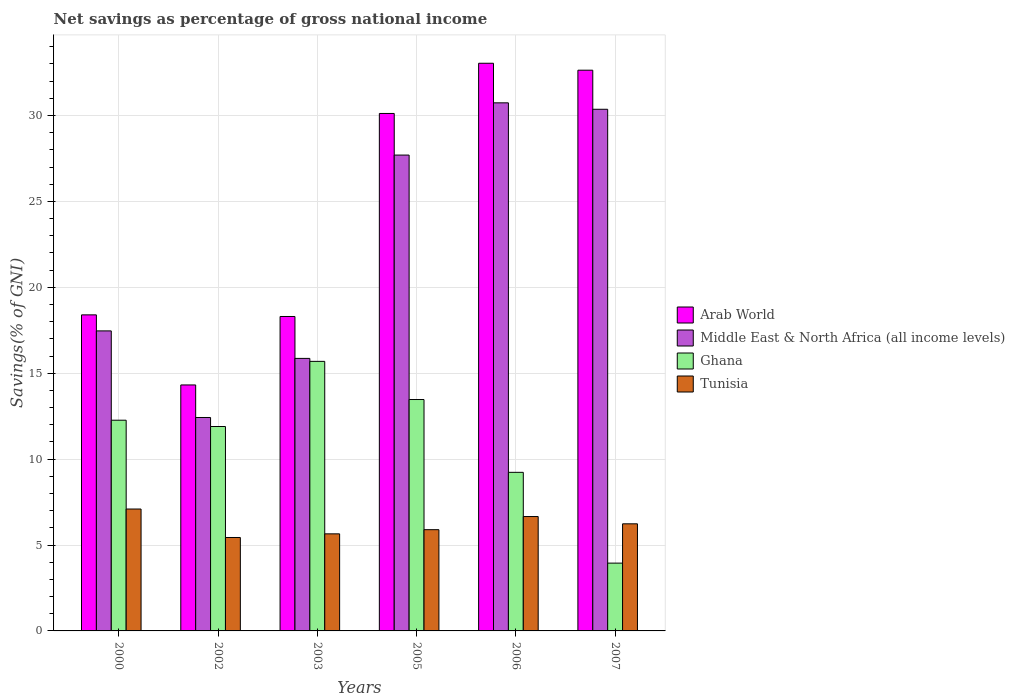Are the number of bars per tick equal to the number of legend labels?
Keep it short and to the point. Yes. How many bars are there on the 5th tick from the right?
Your response must be concise. 4. What is the total savings in Middle East & North Africa (all income levels) in 2002?
Your response must be concise. 12.42. Across all years, what is the maximum total savings in Tunisia?
Provide a succinct answer. 7.09. Across all years, what is the minimum total savings in Middle East & North Africa (all income levels)?
Provide a succinct answer. 12.42. What is the total total savings in Ghana in the graph?
Give a very brief answer. 66.49. What is the difference between the total savings in Tunisia in 2006 and that in 2007?
Give a very brief answer. 0.42. What is the difference between the total savings in Arab World in 2003 and the total savings in Ghana in 2002?
Offer a very short reply. 6.4. What is the average total savings in Tunisia per year?
Provide a succinct answer. 6.16. In the year 2007, what is the difference between the total savings in Tunisia and total savings in Arab World?
Ensure brevity in your answer.  -26.4. In how many years, is the total savings in Tunisia greater than 9 %?
Keep it short and to the point. 0. What is the ratio of the total savings in Tunisia in 2003 to that in 2005?
Your response must be concise. 0.96. Is the total savings in Middle East & North Africa (all income levels) in 2002 less than that in 2007?
Offer a terse response. Yes. Is the difference between the total savings in Tunisia in 2002 and 2007 greater than the difference between the total savings in Arab World in 2002 and 2007?
Make the answer very short. Yes. What is the difference between the highest and the second highest total savings in Ghana?
Make the answer very short. 2.22. What is the difference between the highest and the lowest total savings in Middle East & North Africa (all income levels)?
Your response must be concise. 18.31. What does the 2nd bar from the left in 2002 represents?
Your response must be concise. Middle East & North Africa (all income levels). What does the 1st bar from the right in 2005 represents?
Make the answer very short. Tunisia. Is it the case that in every year, the sum of the total savings in Tunisia and total savings in Ghana is greater than the total savings in Arab World?
Your answer should be very brief. No. Are all the bars in the graph horizontal?
Make the answer very short. No. How many years are there in the graph?
Your answer should be very brief. 6. What is the difference between two consecutive major ticks on the Y-axis?
Keep it short and to the point. 5. Where does the legend appear in the graph?
Your answer should be very brief. Center right. How are the legend labels stacked?
Keep it short and to the point. Vertical. What is the title of the graph?
Keep it short and to the point. Net savings as percentage of gross national income. Does "Malaysia" appear as one of the legend labels in the graph?
Your answer should be compact. No. What is the label or title of the Y-axis?
Make the answer very short. Savings(% of GNI). What is the Savings(% of GNI) of Arab World in 2000?
Provide a short and direct response. 18.39. What is the Savings(% of GNI) in Middle East & North Africa (all income levels) in 2000?
Your answer should be very brief. 17.46. What is the Savings(% of GNI) in Ghana in 2000?
Ensure brevity in your answer.  12.26. What is the Savings(% of GNI) in Tunisia in 2000?
Provide a succinct answer. 7.09. What is the Savings(% of GNI) of Arab World in 2002?
Offer a very short reply. 14.32. What is the Savings(% of GNI) in Middle East & North Africa (all income levels) in 2002?
Provide a succinct answer. 12.42. What is the Savings(% of GNI) of Ghana in 2002?
Your response must be concise. 11.9. What is the Savings(% of GNI) of Tunisia in 2002?
Offer a terse response. 5.44. What is the Savings(% of GNI) in Arab World in 2003?
Offer a terse response. 18.3. What is the Savings(% of GNI) of Middle East & North Africa (all income levels) in 2003?
Your response must be concise. 15.86. What is the Savings(% of GNI) in Ghana in 2003?
Ensure brevity in your answer.  15.69. What is the Savings(% of GNI) in Tunisia in 2003?
Make the answer very short. 5.65. What is the Savings(% of GNI) of Arab World in 2005?
Ensure brevity in your answer.  30.12. What is the Savings(% of GNI) of Middle East & North Africa (all income levels) in 2005?
Your response must be concise. 27.69. What is the Savings(% of GNI) in Ghana in 2005?
Give a very brief answer. 13.47. What is the Savings(% of GNI) in Tunisia in 2005?
Your response must be concise. 5.89. What is the Savings(% of GNI) in Arab World in 2006?
Your response must be concise. 33.04. What is the Savings(% of GNI) of Middle East & North Africa (all income levels) in 2006?
Provide a succinct answer. 30.73. What is the Savings(% of GNI) in Ghana in 2006?
Give a very brief answer. 9.23. What is the Savings(% of GNI) in Tunisia in 2006?
Your answer should be very brief. 6.66. What is the Savings(% of GNI) in Arab World in 2007?
Make the answer very short. 32.63. What is the Savings(% of GNI) of Middle East & North Africa (all income levels) in 2007?
Your answer should be compact. 30.36. What is the Savings(% of GNI) of Ghana in 2007?
Give a very brief answer. 3.95. What is the Savings(% of GNI) of Tunisia in 2007?
Keep it short and to the point. 6.23. Across all years, what is the maximum Savings(% of GNI) of Arab World?
Offer a very short reply. 33.04. Across all years, what is the maximum Savings(% of GNI) in Middle East & North Africa (all income levels)?
Ensure brevity in your answer.  30.73. Across all years, what is the maximum Savings(% of GNI) in Ghana?
Offer a terse response. 15.69. Across all years, what is the maximum Savings(% of GNI) of Tunisia?
Your answer should be compact. 7.09. Across all years, what is the minimum Savings(% of GNI) of Arab World?
Offer a terse response. 14.32. Across all years, what is the minimum Savings(% of GNI) of Middle East & North Africa (all income levels)?
Your answer should be compact. 12.42. Across all years, what is the minimum Savings(% of GNI) of Ghana?
Provide a succinct answer. 3.95. Across all years, what is the minimum Savings(% of GNI) of Tunisia?
Give a very brief answer. 5.44. What is the total Savings(% of GNI) in Arab World in the graph?
Offer a very short reply. 146.8. What is the total Savings(% of GNI) of Middle East & North Africa (all income levels) in the graph?
Provide a short and direct response. 134.53. What is the total Savings(% of GNI) in Ghana in the graph?
Your response must be concise. 66.49. What is the total Savings(% of GNI) in Tunisia in the graph?
Give a very brief answer. 36.96. What is the difference between the Savings(% of GNI) in Arab World in 2000 and that in 2002?
Give a very brief answer. 4.08. What is the difference between the Savings(% of GNI) in Middle East & North Africa (all income levels) in 2000 and that in 2002?
Your answer should be compact. 5.04. What is the difference between the Savings(% of GNI) in Ghana in 2000 and that in 2002?
Your response must be concise. 0.37. What is the difference between the Savings(% of GNI) in Tunisia in 2000 and that in 2002?
Give a very brief answer. 1.66. What is the difference between the Savings(% of GNI) in Arab World in 2000 and that in 2003?
Ensure brevity in your answer.  0.09. What is the difference between the Savings(% of GNI) in Middle East & North Africa (all income levels) in 2000 and that in 2003?
Keep it short and to the point. 1.6. What is the difference between the Savings(% of GNI) of Ghana in 2000 and that in 2003?
Offer a very short reply. -3.42. What is the difference between the Savings(% of GNI) of Tunisia in 2000 and that in 2003?
Give a very brief answer. 1.44. What is the difference between the Savings(% of GNI) of Arab World in 2000 and that in 2005?
Your answer should be very brief. -11.72. What is the difference between the Savings(% of GNI) of Middle East & North Africa (all income levels) in 2000 and that in 2005?
Offer a very short reply. -10.23. What is the difference between the Savings(% of GNI) in Ghana in 2000 and that in 2005?
Keep it short and to the point. -1.2. What is the difference between the Savings(% of GNI) of Tunisia in 2000 and that in 2005?
Your answer should be compact. 1.2. What is the difference between the Savings(% of GNI) of Arab World in 2000 and that in 2006?
Offer a very short reply. -14.64. What is the difference between the Savings(% of GNI) of Middle East & North Africa (all income levels) in 2000 and that in 2006?
Keep it short and to the point. -13.27. What is the difference between the Savings(% of GNI) in Ghana in 2000 and that in 2006?
Ensure brevity in your answer.  3.03. What is the difference between the Savings(% of GNI) in Tunisia in 2000 and that in 2006?
Your response must be concise. 0.44. What is the difference between the Savings(% of GNI) of Arab World in 2000 and that in 2007?
Make the answer very short. -14.24. What is the difference between the Savings(% of GNI) in Middle East & North Africa (all income levels) in 2000 and that in 2007?
Your response must be concise. -12.9. What is the difference between the Savings(% of GNI) in Ghana in 2000 and that in 2007?
Keep it short and to the point. 8.32. What is the difference between the Savings(% of GNI) in Tunisia in 2000 and that in 2007?
Your answer should be very brief. 0.86. What is the difference between the Savings(% of GNI) in Arab World in 2002 and that in 2003?
Offer a terse response. -3.98. What is the difference between the Savings(% of GNI) in Middle East & North Africa (all income levels) in 2002 and that in 2003?
Keep it short and to the point. -3.44. What is the difference between the Savings(% of GNI) of Ghana in 2002 and that in 2003?
Your answer should be compact. -3.79. What is the difference between the Savings(% of GNI) of Tunisia in 2002 and that in 2003?
Offer a very short reply. -0.21. What is the difference between the Savings(% of GNI) in Arab World in 2002 and that in 2005?
Provide a succinct answer. -15.8. What is the difference between the Savings(% of GNI) of Middle East & North Africa (all income levels) in 2002 and that in 2005?
Your answer should be compact. -15.27. What is the difference between the Savings(% of GNI) of Ghana in 2002 and that in 2005?
Your response must be concise. -1.57. What is the difference between the Savings(% of GNI) of Tunisia in 2002 and that in 2005?
Offer a terse response. -0.45. What is the difference between the Savings(% of GNI) of Arab World in 2002 and that in 2006?
Make the answer very short. -18.72. What is the difference between the Savings(% of GNI) of Middle East & North Africa (all income levels) in 2002 and that in 2006?
Provide a short and direct response. -18.31. What is the difference between the Savings(% of GNI) in Ghana in 2002 and that in 2006?
Provide a succinct answer. 2.67. What is the difference between the Savings(% of GNI) of Tunisia in 2002 and that in 2006?
Make the answer very short. -1.22. What is the difference between the Savings(% of GNI) of Arab World in 2002 and that in 2007?
Provide a succinct answer. -18.32. What is the difference between the Savings(% of GNI) in Middle East & North Africa (all income levels) in 2002 and that in 2007?
Your answer should be compact. -17.94. What is the difference between the Savings(% of GNI) of Ghana in 2002 and that in 2007?
Keep it short and to the point. 7.95. What is the difference between the Savings(% of GNI) of Tunisia in 2002 and that in 2007?
Offer a terse response. -0.8. What is the difference between the Savings(% of GNI) in Arab World in 2003 and that in 2005?
Provide a short and direct response. -11.82. What is the difference between the Savings(% of GNI) in Middle East & North Africa (all income levels) in 2003 and that in 2005?
Offer a very short reply. -11.83. What is the difference between the Savings(% of GNI) in Ghana in 2003 and that in 2005?
Keep it short and to the point. 2.22. What is the difference between the Savings(% of GNI) of Tunisia in 2003 and that in 2005?
Ensure brevity in your answer.  -0.24. What is the difference between the Savings(% of GNI) of Arab World in 2003 and that in 2006?
Make the answer very short. -14.74. What is the difference between the Savings(% of GNI) of Middle East & North Africa (all income levels) in 2003 and that in 2006?
Ensure brevity in your answer.  -14.87. What is the difference between the Savings(% of GNI) in Ghana in 2003 and that in 2006?
Ensure brevity in your answer.  6.46. What is the difference between the Savings(% of GNI) in Tunisia in 2003 and that in 2006?
Your response must be concise. -1.01. What is the difference between the Savings(% of GNI) in Arab World in 2003 and that in 2007?
Ensure brevity in your answer.  -14.33. What is the difference between the Savings(% of GNI) of Middle East & North Africa (all income levels) in 2003 and that in 2007?
Keep it short and to the point. -14.5. What is the difference between the Savings(% of GNI) in Ghana in 2003 and that in 2007?
Your answer should be very brief. 11.74. What is the difference between the Savings(% of GNI) in Tunisia in 2003 and that in 2007?
Offer a terse response. -0.58. What is the difference between the Savings(% of GNI) in Arab World in 2005 and that in 2006?
Your answer should be very brief. -2.92. What is the difference between the Savings(% of GNI) in Middle East & North Africa (all income levels) in 2005 and that in 2006?
Give a very brief answer. -3.04. What is the difference between the Savings(% of GNI) of Ghana in 2005 and that in 2006?
Offer a terse response. 4.24. What is the difference between the Savings(% of GNI) of Tunisia in 2005 and that in 2006?
Your response must be concise. -0.77. What is the difference between the Savings(% of GNI) of Arab World in 2005 and that in 2007?
Give a very brief answer. -2.52. What is the difference between the Savings(% of GNI) in Middle East & North Africa (all income levels) in 2005 and that in 2007?
Give a very brief answer. -2.67. What is the difference between the Savings(% of GNI) of Ghana in 2005 and that in 2007?
Your response must be concise. 9.52. What is the difference between the Savings(% of GNI) in Tunisia in 2005 and that in 2007?
Keep it short and to the point. -0.34. What is the difference between the Savings(% of GNI) of Arab World in 2006 and that in 2007?
Provide a succinct answer. 0.4. What is the difference between the Savings(% of GNI) in Middle East & North Africa (all income levels) in 2006 and that in 2007?
Make the answer very short. 0.37. What is the difference between the Savings(% of GNI) in Ghana in 2006 and that in 2007?
Your answer should be compact. 5.28. What is the difference between the Savings(% of GNI) in Tunisia in 2006 and that in 2007?
Offer a terse response. 0.42. What is the difference between the Savings(% of GNI) of Arab World in 2000 and the Savings(% of GNI) of Middle East & North Africa (all income levels) in 2002?
Your answer should be very brief. 5.97. What is the difference between the Savings(% of GNI) in Arab World in 2000 and the Savings(% of GNI) in Ghana in 2002?
Your answer should be compact. 6.5. What is the difference between the Savings(% of GNI) in Arab World in 2000 and the Savings(% of GNI) in Tunisia in 2002?
Offer a very short reply. 12.96. What is the difference between the Savings(% of GNI) of Middle East & North Africa (all income levels) in 2000 and the Savings(% of GNI) of Ghana in 2002?
Ensure brevity in your answer.  5.57. What is the difference between the Savings(% of GNI) of Middle East & North Africa (all income levels) in 2000 and the Savings(% of GNI) of Tunisia in 2002?
Offer a very short reply. 12.02. What is the difference between the Savings(% of GNI) of Ghana in 2000 and the Savings(% of GNI) of Tunisia in 2002?
Provide a succinct answer. 6.83. What is the difference between the Savings(% of GNI) of Arab World in 2000 and the Savings(% of GNI) of Middle East & North Africa (all income levels) in 2003?
Offer a terse response. 2.53. What is the difference between the Savings(% of GNI) of Arab World in 2000 and the Savings(% of GNI) of Ghana in 2003?
Ensure brevity in your answer.  2.71. What is the difference between the Savings(% of GNI) in Arab World in 2000 and the Savings(% of GNI) in Tunisia in 2003?
Your response must be concise. 12.75. What is the difference between the Savings(% of GNI) of Middle East & North Africa (all income levels) in 2000 and the Savings(% of GNI) of Ghana in 2003?
Keep it short and to the point. 1.77. What is the difference between the Savings(% of GNI) in Middle East & North Africa (all income levels) in 2000 and the Savings(% of GNI) in Tunisia in 2003?
Offer a terse response. 11.81. What is the difference between the Savings(% of GNI) of Ghana in 2000 and the Savings(% of GNI) of Tunisia in 2003?
Give a very brief answer. 6.61. What is the difference between the Savings(% of GNI) of Arab World in 2000 and the Savings(% of GNI) of Middle East & North Africa (all income levels) in 2005?
Make the answer very short. -9.3. What is the difference between the Savings(% of GNI) in Arab World in 2000 and the Savings(% of GNI) in Ghana in 2005?
Provide a short and direct response. 4.93. What is the difference between the Savings(% of GNI) of Arab World in 2000 and the Savings(% of GNI) of Tunisia in 2005?
Provide a succinct answer. 12.5. What is the difference between the Savings(% of GNI) of Middle East & North Africa (all income levels) in 2000 and the Savings(% of GNI) of Ghana in 2005?
Your answer should be compact. 3.99. What is the difference between the Savings(% of GNI) of Middle East & North Africa (all income levels) in 2000 and the Savings(% of GNI) of Tunisia in 2005?
Provide a short and direct response. 11.57. What is the difference between the Savings(% of GNI) in Ghana in 2000 and the Savings(% of GNI) in Tunisia in 2005?
Offer a very short reply. 6.37. What is the difference between the Savings(% of GNI) of Arab World in 2000 and the Savings(% of GNI) of Middle East & North Africa (all income levels) in 2006?
Offer a terse response. -12.34. What is the difference between the Savings(% of GNI) in Arab World in 2000 and the Savings(% of GNI) in Ghana in 2006?
Provide a succinct answer. 9.16. What is the difference between the Savings(% of GNI) in Arab World in 2000 and the Savings(% of GNI) in Tunisia in 2006?
Offer a terse response. 11.74. What is the difference between the Savings(% of GNI) in Middle East & North Africa (all income levels) in 2000 and the Savings(% of GNI) in Ghana in 2006?
Provide a succinct answer. 8.23. What is the difference between the Savings(% of GNI) in Middle East & North Africa (all income levels) in 2000 and the Savings(% of GNI) in Tunisia in 2006?
Your answer should be compact. 10.8. What is the difference between the Savings(% of GNI) in Ghana in 2000 and the Savings(% of GNI) in Tunisia in 2006?
Give a very brief answer. 5.61. What is the difference between the Savings(% of GNI) in Arab World in 2000 and the Savings(% of GNI) in Middle East & North Africa (all income levels) in 2007?
Provide a succinct answer. -11.97. What is the difference between the Savings(% of GNI) in Arab World in 2000 and the Savings(% of GNI) in Ghana in 2007?
Make the answer very short. 14.45. What is the difference between the Savings(% of GNI) in Arab World in 2000 and the Savings(% of GNI) in Tunisia in 2007?
Offer a terse response. 12.16. What is the difference between the Savings(% of GNI) of Middle East & North Africa (all income levels) in 2000 and the Savings(% of GNI) of Ghana in 2007?
Offer a terse response. 13.52. What is the difference between the Savings(% of GNI) of Middle East & North Africa (all income levels) in 2000 and the Savings(% of GNI) of Tunisia in 2007?
Offer a very short reply. 11.23. What is the difference between the Savings(% of GNI) of Ghana in 2000 and the Savings(% of GNI) of Tunisia in 2007?
Provide a succinct answer. 6.03. What is the difference between the Savings(% of GNI) in Arab World in 2002 and the Savings(% of GNI) in Middle East & North Africa (all income levels) in 2003?
Make the answer very short. -1.54. What is the difference between the Savings(% of GNI) of Arab World in 2002 and the Savings(% of GNI) of Ghana in 2003?
Offer a terse response. -1.37. What is the difference between the Savings(% of GNI) in Arab World in 2002 and the Savings(% of GNI) in Tunisia in 2003?
Make the answer very short. 8.67. What is the difference between the Savings(% of GNI) in Middle East & North Africa (all income levels) in 2002 and the Savings(% of GNI) in Ghana in 2003?
Offer a terse response. -3.27. What is the difference between the Savings(% of GNI) of Middle East & North Africa (all income levels) in 2002 and the Savings(% of GNI) of Tunisia in 2003?
Keep it short and to the point. 6.77. What is the difference between the Savings(% of GNI) in Ghana in 2002 and the Savings(% of GNI) in Tunisia in 2003?
Offer a very short reply. 6.25. What is the difference between the Savings(% of GNI) in Arab World in 2002 and the Savings(% of GNI) in Middle East & North Africa (all income levels) in 2005?
Keep it short and to the point. -13.38. What is the difference between the Savings(% of GNI) in Arab World in 2002 and the Savings(% of GNI) in Ghana in 2005?
Offer a terse response. 0.85. What is the difference between the Savings(% of GNI) in Arab World in 2002 and the Savings(% of GNI) in Tunisia in 2005?
Your answer should be compact. 8.42. What is the difference between the Savings(% of GNI) of Middle East & North Africa (all income levels) in 2002 and the Savings(% of GNI) of Ghana in 2005?
Offer a very short reply. -1.05. What is the difference between the Savings(% of GNI) of Middle East & North Africa (all income levels) in 2002 and the Savings(% of GNI) of Tunisia in 2005?
Keep it short and to the point. 6.53. What is the difference between the Savings(% of GNI) in Ghana in 2002 and the Savings(% of GNI) in Tunisia in 2005?
Keep it short and to the point. 6. What is the difference between the Savings(% of GNI) of Arab World in 2002 and the Savings(% of GNI) of Middle East & North Africa (all income levels) in 2006?
Offer a very short reply. -16.42. What is the difference between the Savings(% of GNI) of Arab World in 2002 and the Savings(% of GNI) of Ghana in 2006?
Offer a very short reply. 5.09. What is the difference between the Savings(% of GNI) in Arab World in 2002 and the Savings(% of GNI) in Tunisia in 2006?
Ensure brevity in your answer.  7.66. What is the difference between the Savings(% of GNI) in Middle East & North Africa (all income levels) in 2002 and the Savings(% of GNI) in Ghana in 2006?
Offer a terse response. 3.19. What is the difference between the Savings(% of GNI) of Middle East & North Africa (all income levels) in 2002 and the Savings(% of GNI) of Tunisia in 2006?
Your answer should be compact. 5.76. What is the difference between the Savings(% of GNI) in Ghana in 2002 and the Savings(% of GNI) in Tunisia in 2006?
Your response must be concise. 5.24. What is the difference between the Savings(% of GNI) in Arab World in 2002 and the Savings(% of GNI) in Middle East & North Africa (all income levels) in 2007?
Offer a very short reply. -16.04. What is the difference between the Savings(% of GNI) in Arab World in 2002 and the Savings(% of GNI) in Ghana in 2007?
Provide a succinct answer. 10.37. What is the difference between the Savings(% of GNI) in Arab World in 2002 and the Savings(% of GNI) in Tunisia in 2007?
Give a very brief answer. 8.08. What is the difference between the Savings(% of GNI) of Middle East & North Africa (all income levels) in 2002 and the Savings(% of GNI) of Ghana in 2007?
Ensure brevity in your answer.  8.48. What is the difference between the Savings(% of GNI) of Middle East & North Africa (all income levels) in 2002 and the Savings(% of GNI) of Tunisia in 2007?
Provide a short and direct response. 6.19. What is the difference between the Savings(% of GNI) of Ghana in 2002 and the Savings(% of GNI) of Tunisia in 2007?
Ensure brevity in your answer.  5.66. What is the difference between the Savings(% of GNI) of Arab World in 2003 and the Savings(% of GNI) of Middle East & North Africa (all income levels) in 2005?
Your answer should be very brief. -9.39. What is the difference between the Savings(% of GNI) in Arab World in 2003 and the Savings(% of GNI) in Ghana in 2005?
Provide a succinct answer. 4.83. What is the difference between the Savings(% of GNI) in Arab World in 2003 and the Savings(% of GNI) in Tunisia in 2005?
Offer a very short reply. 12.41. What is the difference between the Savings(% of GNI) of Middle East & North Africa (all income levels) in 2003 and the Savings(% of GNI) of Ghana in 2005?
Provide a short and direct response. 2.39. What is the difference between the Savings(% of GNI) in Middle East & North Africa (all income levels) in 2003 and the Savings(% of GNI) in Tunisia in 2005?
Ensure brevity in your answer.  9.97. What is the difference between the Savings(% of GNI) of Ghana in 2003 and the Savings(% of GNI) of Tunisia in 2005?
Your answer should be compact. 9.8. What is the difference between the Savings(% of GNI) in Arab World in 2003 and the Savings(% of GNI) in Middle East & North Africa (all income levels) in 2006?
Provide a short and direct response. -12.43. What is the difference between the Savings(% of GNI) of Arab World in 2003 and the Savings(% of GNI) of Ghana in 2006?
Your response must be concise. 9.07. What is the difference between the Savings(% of GNI) in Arab World in 2003 and the Savings(% of GNI) in Tunisia in 2006?
Keep it short and to the point. 11.64. What is the difference between the Savings(% of GNI) of Middle East & North Africa (all income levels) in 2003 and the Savings(% of GNI) of Ghana in 2006?
Provide a succinct answer. 6.63. What is the difference between the Savings(% of GNI) in Middle East & North Africa (all income levels) in 2003 and the Savings(% of GNI) in Tunisia in 2006?
Provide a short and direct response. 9.2. What is the difference between the Savings(% of GNI) of Ghana in 2003 and the Savings(% of GNI) of Tunisia in 2006?
Offer a terse response. 9.03. What is the difference between the Savings(% of GNI) of Arab World in 2003 and the Savings(% of GNI) of Middle East & North Africa (all income levels) in 2007?
Your response must be concise. -12.06. What is the difference between the Savings(% of GNI) of Arab World in 2003 and the Savings(% of GNI) of Ghana in 2007?
Provide a short and direct response. 14.35. What is the difference between the Savings(% of GNI) of Arab World in 2003 and the Savings(% of GNI) of Tunisia in 2007?
Keep it short and to the point. 12.07. What is the difference between the Savings(% of GNI) of Middle East & North Africa (all income levels) in 2003 and the Savings(% of GNI) of Ghana in 2007?
Your answer should be compact. 11.91. What is the difference between the Savings(% of GNI) of Middle East & North Africa (all income levels) in 2003 and the Savings(% of GNI) of Tunisia in 2007?
Keep it short and to the point. 9.63. What is the difference between the Savings(% of GNI) of Ghana in 2003 and the Savings(% of GNI) of Tunisia in 2007?
Your answer should be compact. 9.45. What is the difference between the Savings(% of GNI) of Arab World in 2005 and the Savings(% of GNI) of Middle East & North Africa (all income levels) in 2006?
Ensure brevity in your answer.  -0.62. What is the difference between the Savings(% of GNI) of Arab World in 2005 and the Savings(% of GNI) of Ghana in 2006?
Your response must be concise. 20.89. What is the difference between the Savings(% of GNI) in Arab World in 2005 and the Savings(% of GNI) in Tunisia in 2006?
Your answer should be compact. 23.46. What is the difference between the Savings(% of GNI) in Middle East & North Africa (all income levels) in 2005 and the Savings(% of GNI) in Ghana in 2006?
Ensure brevity in your answer.  18.46. What is the difference between the Savings(% of GNI) in Middle East & North Africa (all income levels) in 2005 and the Savings(% of GNI) in Tunisia in 2006?
Give a very brief answer. 21.04. What is the difference between the Savings(% of GNI) of Ghana in 2005 and the Savings(% of GNI) of Tunisia in 2006?
Your answer should be compact. 6.81. What is the difference between the Savings(% of GNI) of Arab World in 2005 and the Savings(% of GNI) of Middle East & North Africa (all income levels) in 2007?
Provide a short and direct response. -0.24. What is the difference between the Savings(% of GNI) in Arab World in 2005 and the Savings(% of GNI) in Ghana in 2007?
Make the answer very short. 26.17. What is the difference between the Savings(% of GNI) of Arab World in 2005 and the Savings(% of GNI) of Tunisia in 2007?
Offer a very short reply. 23.88. What is the difference between the Savings(% of GNI) of Middle East & North Africa (all income levels) in 2005 and the Savings(% of GNI) of Ghana in 2007?
Ensure brevity in your answer.  23.75. What is the difference between the Savings(% of GNI) of Middle East & North Africa (all income levels) in 2005 and the Savings(% of GNI) of Tunisia in 2007?
Your answer should be compact. 21.46. What is the difference between the Savings(% of GNI) of Ghana in 2005 and the Savings(% of GNI) of Tunisia in 2007?
Offer a very short reply. 7.23. What is the difference between the Savings(% of GNI) in Arab World in 2006 and the Savings(% of GNI) in Middle East & North Africa (all income levels) in 2007?
Your answer should be very brief. 2.68. What is the difference between the Savings(% of GNI) of Arab World in 2006 and the Savings(% of GNI) of Ghana in 2007?
Your answer should be very brief. 29.09. What is the difference between the Savings(% of GNI) in Arab World in 2006 and the Savings(% of GNI) in Tunisia in 2007?
Provide a succinct answer. 26.8. What is the difference between the Savings(% of GNI) in Middle East & North Africa (all income levels) in 2006 and the Savings(% of GNI) in Ghana in 2007?
Give a very brief answer. 26.79. What is the difference between the Savings(% of GNI) in Middle East & North Africa (all income levels) in 2006 and the Savings(% of GNI) in Tunisia in 2007?
Provide a short and direct response. 24.5. What is the difference between the Savings(% of GNI) in Ghana in 2006 and the Savings(% of GNI) in Tunisia in 2007?
Your answer should be compact. 3. What is the average Savings(% of GNI) of Arab World per year?
Your response must be concise. 24.47. What is the average Savings(% of GNI) in Middle East & North Africa (all income levels) per year?
Make the answer very short. 22.42. What is the average Savings(% of GNI) of Ghana per year?
Provide a succinct answer. 11.08. What is the average Savings(% of GNI) in Tunisia per year?
Provide a short and direct response. 6.16. In the year 2000, what is the difference between the Savings(% of GNI) in Arab World and Savings(% of GNI) in Middle East & North Africa (all income levels)?
Give a very brief answer. 0.93. In the year 2000, what is the difference between the Savings(% of GNI) of Arab World and Savings(% of GNI) of Ghana?
Offer a very short reply. 6.13. In the year 2000, what is the difference between the Savings(% of GNI) of Arab World and Savings(% of GNI) of Tunisia?
Your answer should be compact. 11.3. In the year 2000, what is the difference between the Savings(% of GNI) in Middle East & North Africa (all income levels) and Savings(% of GNI) in Ghana?
Make the answer very short. 5.2. In the year 2000, what is the difference between the Savings(% of GNI) in Middle East & North Africa (all income levels) and Savings(% of GNI) in Tunisia?
Offer a very short reply. 10.37. In the year 2000, what is the difference between the Savings(% of GNI) of Ghana and Savings(% of GNI) of Tunisia?
Make the answer very short. 5.17. In the year 2002, what is the difference between the Savings(% of GNI) in Arab World and Savings(% of GNI) in Middle East & North Africa (all income levels)?
Keep it short and to the point. 1.89. In the year 2002, what is the difference between the Savings(% of GNI) in Arab World and Savings(% of GNI) in Ghana?
Give a very brief answer. 2.42. In the year 2002, what is the difference between the Savings(% of GNI) of Arab World and Savings(% of GNI) of Tunisia?
Ensure brevity in your answer.  8.88. In the year 2002, what is the difference between the Savings(% of GNI) of Middle East & North Africa (all income levels) and Savings(% of GNI) of Ghana?
Give a very brief answer. 0.53. In the year 2002, what is the difference between the Savings(% of GNI) of Middle East & North Africa (all income levels) and Savings(% of GNI) of Tunisia?
Make the answer very short. 6.98. In the year 2002, what is the difference between the Savings(% of GNI) of Ghana and Savings(% of GNI) of Tunisia?
Keep it short and to the point. 6.46. In the year 2003, what is the difference between the Savings(% of GNI) of Arab World and Savings(% of GNI) of Middle East & North Africa (all income levels)?
Ensure brevity in your answer.  2.44. In the year 2003, what is the difference between the Savings(% of GNI) of Arab World and Savings(% of GNI) of Ghana?
Your answer should be very brief. 2.61. In the year 2003, what is the difference between the Savings(% of GNI) of Arab World and Savings(% of GNI) of Tunisia?
Ensure brevity in your answer.  12.65. In the year 2003, what is the difference between the Savings(% of GNI) in Middle East & North Africa (all income levels) and Savings(% of GNI) in Ghana?
Offer a terse response. 0.17. In the year 2003, what is the difference between the Savings(% of GNI) of Middle East & North Africa (all income levels) and Savings(% of GNI) of Tunisia?
Make the answer very short. 10.21. In the year 2003, what is the difference between the Savings(% of GNI) of Ghana and Savings(% of GNI) of Tunisia?
Ensure brevity in your answer.  10.04. In the year 2005, what is the difference between the Savings(% of GNI) in Arab World and Savings(% of GNI) in Middle East & North Africa (all income levels)?
Offer a terse response. 2.42. In the year 2005, what is the difference between the Savings(% of GNI) of Arab World and Savings(% of GNI) of Ghana?
Make the answer very short. 16.65. In the year 2005, what is the difference between the Savings(% of GNI) of Arab World and Savings(% of GNI) of Tunisia?
Make the answer very short. 24.22. In the year 2005, what is the difference between the Savings(% of GNI) in Middle East & North Africa (all income levels) and Savings(% of GNI) in Ghana?
Offer a very short reply. 14.23. In the year 2005, what is the difference between the Savings(% of GNI) of Middle East & North Africa (all income levels) and Savings(% of GNI) of Tunisia?
Keep it short and to the point. 21.8. In the year 2005, what is the difference between the Savings(% of GNI) in Ghana and Savings(% of GNI) in Tunisia?
Keep it short and to the point. 7.58. In the year 2006, what is the difference between the Savings(% of GNI) in Arab World and Savings(% of GNI) in Middle East & North Africa (all income levels)?
Offer a very short reply. 2.3. In the year 2006, what is the difference between the Savings(% of GNI) of Arab World and Savings(% of GNI) of Ghana?
Provide a succinct answer. 23.81. In the year 2006, what is the difference between the Savings(% of GNI) in Arab World and Savings(% of GNI) in Tunisia?
Make the answer very short. 26.38. In the year 2006, what is the difference between the Savings(% of GNI) in Middle East & North Africa (all income levels) and Savings(% of GNI) in Ghana?
Provide a succinct answer. 21.5. In the year 2006, what is the difference between the Savings(% of GNI) of Middle East & North Africa (all income levels) and Savings(% of GNI) of Tunisia?
Keep it short and to the point. 24.08. In the year 2006, what is the difference between the Savings(% of GNI) in Ghana and Savings(% of GNI) in Tunisia?
Keep it short and to the point. 2.57. In the year 2007, what is the difference between the Savings(% of GNI) of Arab World and Savings(% of GNI) of Middle East & North Africa (all income levels)?
Make the answer very short. 2.27. In the year 2007, what is the difference between the Savings(% of GNI) in Arab World and Savings(% of GNI) in Ghana?
Provide a short and direct response. 28.69. In the year 2007, what is the difference between the Savings(% of GNI) of Arab World and Savings(% of GNI) of Tunisia?
Make the answer very short. 26.4. In the year 2007, what is the difference between the Savings(% of GNI) in Middle East & North Africa (all income levels) and Savings(% of GNI) in Ghana?
Offer a terse response. 26.41. In the year 2007, what is the difference between the Savings(% of GNI) of Middle East & North Africa (all income levels) and Savings(% of GNI) of Tunisia?
Make the answer very short. 24.13. In the year 2007, what is the difference between the Savings(% of GNI) in Ghana and Savings(% of GNI) in Tunisia?
Your answer should be compact. -2.29. What is the ratio of the Savings(% of GNI) of Arab World in 2000 to that in 2002?
Your answer should be compact. 1.28. What is the ratio of the Savings(% of GNI) of Middle East & North Africa (all income levels) in 2000 to that in 2002?
Your response must be concise. 1.41. What is the ratio of the Savings(% of GNI) of Ghana in 2000 to that in 2002?
Your answer should be compact. 1.03. What is the ratio of the Savings(% of GNI) in Tunisia in 2000 to that in 2002?
Offer a terse response. 1.3. What is the ratio of the Savings(% of GNI) in Middle East & North Africa (all income levels) in 2000 to that in 2003?
Provide a short and direct response. 1.1. What is the ratio of the Savings(% of GNI) of Ghana in 2000 to that in 2003?
Make the answer very short. 0.78. What is the ratio of the Savings(% of GNI) of Tunisia in 2000 to that in 2003?
Offer a terse response. 1.26. What is the ratio of the Savings(% of GNI) in Arab World in 2000 to that in 2005?
Your answer should be very brief. 0.61. What is the ratio of the Savings(% of GNI) in Middle East & North Africa (all income levels) in 2000 to that in 2005?
Your response must be concise. 0.63. What is the ratio of the Savings(% of GNI) in Ghana in 2000 to that in 2005?
Give a very brief answer. 0.91. What is the ratio of the Savings(% of GNI) in Tunisia in 2000 to that in 2005?
Your answer should be compact. 1.2. What is the ratio of the Savings(% of GNI) of Arab World in 2000 to that in 2006?
Keep it short and to the point. 0.56. What is the ratio of the Savings(% of GNI) of Middle East & North Africa (all income levels) in 2000 to that in 2006?
Provide a succinct answer. 0.57. What is the ratio of the Savings(% of GNI) of Ghana in 2000 to that in 2006?
Your response must be concise. 1.33. What is the ratio of the Savings(% of GNI) of Tunisia in 2000 to that in 2006?
Offer a terse response. 1.07. What is the ratio of the Savings(% of GNI) of Arab World in 2000 to that in 2007?
Make the answer very short. 0.56. What is the ratio of the Savings(% of GNI) of Middle East & North Africa (all income levels) in 2000 to that in 2007?
Your answer should be compact. 0.58. What is the ratio of the Savings(% of GNI) in Ghana in 2000 to that in 2007?
Ensure brevity in your answer.  3.11. What is the ratio of the Savings(% of GNI) in Tunisia in 2000 to that in 2007?
Give a very brief answer. 1.14. What is the ratio of the Savings(% of GNI) in Arab World in 2002 to that in 2003?
Keep it short and to the point. 0.78. What is the ratio of the Savings(% of GNI) of Middle East & North Africa (all income levels) in 2002 to that in 2003?
Make the answer very short. 0.78. What is the ratio of the Savings(% of GNI) of Ghana in 2002 to that in 2003?
Ensure brevity in your answer.  0.76. What is the ratio of the Savings(% of GNI) in Tunisia in 2002 to that in 2003?
Your answer should be compact. 0.96. What is the ratio of the Savings(% of GNI) in Arab World in 2002 to that in 2005?
Your answer should be very brief. 0.48. What is the ratio of the Savings(% of GNI) in Middle East & North Africa (all income levels) in 2002 to that in 2005?
Keep it short and to the point. 0.45. What is the ratio of the Savings(% of GNI) in Ghana in 2002 to that in 2005?
Provide a short and direct response. 0.88. What is the ratio of the Savings(% of GNI) in Tunisia in 2002 to that in 2005?
Provide a short and direct response. 0.92. What is the ratio of the Savings(% of GNI) of Arab World in 2002 to that in 2006?
Provide a short and direct response. 0.43. What is the ratio of the Savings(% of GNI) of Middle East & North Africa (all income levels) in 2002 to that in 2006?
Keep it short and to the point. 0.4. What is the ratio of the Savings(% of GNI) in Ghana in 2002 to that in 2006?
Your answer should be very brief. 1.29. What is the ratio of the Savings(% of GNI) of Tunisia in 2002 to that in 2006?
Provide a succinct answer. 0.82. What is the ratio of the Savings(% of GNI) in Arab World in 2002 to that in 2007?
Offer a terse response. 0.44. What is the ratio of the Savings(% of GNI) in Middle East & North Africa (all income levels) in 2002 to that in 2007?
Offer a terse response. 0.41. What is the ratio of the Savings(% of GNI) of Ghana in 2002 to that in 2007?
Ensure brevity in your answer.  3.01. What is the ratio of the Savings(% of GNI) of Tunisia in 2002 to that in 2007?
Provide a succinct answer. 0.87. What is the ratio of the Savings(% of GNI) of Arab World in 2003 to that in 2005?
Offer a very short reply. 0.61. What is the ratio of the Savings(% of GNI) in Middle East & North Africa (all income levels) in 2003 to that in 2005?
Give a very brief answer. 0.57. What is the ratio of the Savings(% of GNI) in Ghana in 2003 to that in 2005?
Your response must be concise. 1.16. What is the ratio of the Savings(% of GNI) in Tunisia in 2003 to that in 2005?
Provide a succinct answer. 0.96. What is the ratio of the Savings(% of GNI) of Arab World in 2003 to that in 2006?
Provide a short and direct response. 0.55. What is the ratio of the Savings(% of GNI) of Middle East & North Africa (all income levels) in 2003 to that in 2006?
Offer a terse response. 0.52. What is the ratio of the Savings(% of GNI) of Ghana in 2003 to that in 2006?
Your response must be concise. 1.7. What is the ratio of the Savings(% of GNI) in Tunisia in 2003 to that in 2006?
Your answer should be compact. 0.85. What is the ratio of the Savings(% of GNI) in Arab World in 2003 to that in 2007?
Your answer should be compact. 0.56. What is the ratio of the Savings(% of GNI) of Middle East & North Africa (all income levels) in 2003 to that in 2007?
Provide a succinct answer. 0.52. What is the ratio of the Savings(% of GNI) of Ghana in 2003 to that in 2007?
Your answer should be very brief. 3.98. What is the ratio of the Savings(% of GNI) of Tunisia in 2003 to that in 2007?
Keep it short and to the point. 0.91. What is the ratio of the Savings(% of GNI) in Arab World in 2005 to that in 2006?
Ensure brevity in your answer.  0.91. What is the ratio of the Savings(% of GNI) in Middle East & North Africa (all income levels) in 2005 to that in 2006?
Offer a terse response. 0.9. What is the ratio of the Savings(% of GNI) of Ghana in 2005 to that in 2006?
Provide a succinct answer. 1.46. What is the ratio of the Savings(% of GNI) of Tunisia in 2005 to that in 2006?
Provide a succinct answer. 0.89. What is the ratio of the Savings(% of GNI) of Arab World in 2005 to that in 2007?
Ensure brevity in your answer.  0.92. What is the ratio of the Savings(% of GNI) in Middle East & North Africa (all income levels) in 2005 to that in 2007?
Your response must be concise. 0.91. What is the ratio of the Savings(% of GNI) in Ghana in 2005 to that in 2007?
Offer a very short reply. 3.41. What is the ratio of the Savings(% of GNI) of Tunisia in 2005 to that in 2007?
Give a very brief answer. 0.95. What is the ratio of the Savings(% of GNI) of Arab World in 2006 to that in 2007?
Provide a succinct answer. 1.01. What is the ratio of the Savings(% of GNI) of Middle East & North Africa (all income levels) in 2006 to that in 2007?
Your answer should be compact. 1.01. What is the ratio of the Savings(% of GNI) in Ghana in 2006 to that in 2007?
Provide a succinct answer. 2.34. What is the ratio of the Savings(% of GNI) of Tunisia in 2006 to that in 2007?
Your answer should be very brief. 1.07. What is the difference between the highest and the second highest Savings(% of GNI) in Arab World?
Offer a very short reply. 0.4. What is the difference between the highest and the second highest Savings(% of GNI) of Middle East & North Africa (all income levels)?
Your response must be concise. 0.37. What is the difference between the highest and the second highest Savings(% of GNI) of Ghana?
Your response must be concise. 2.22. What is the difference between the highest and the second highest Savings(% of GNI) of Tunisia?
Offer a terse response. 0.44. What is the difference between the highest and the lowest Savings(% of GNI) in Arab World?
Keep it short and to the point. 18.72. What is the difference between the highest and the lowest Savings(% of GNI) of Middle East & North Africa (all income levels)?
Ensure brevity in your answer.  18.31. What is the difference between the highest and the lowest Savings(% of GNI) of Ghana?
Keep it short and to the point. 11.74. What is the difference between the highest and the lowest Savings(% of GNI) of Tunisia?
Your response must be concise. 1.66. 